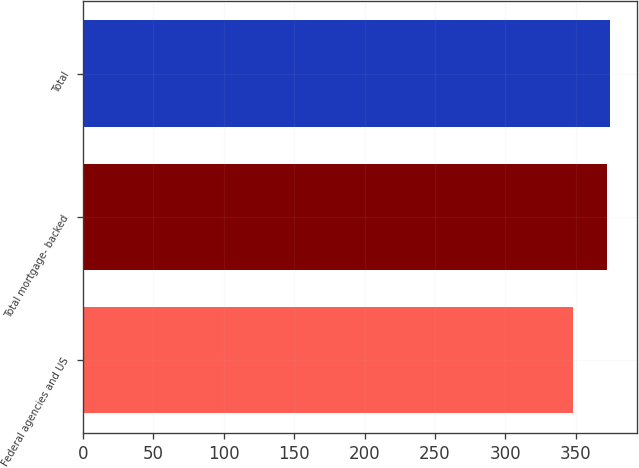Convert chart. <chart><loc_0><loc_0><loc_500><loc_500><bar_chart><fcel>Federal agencies and US<fcel>Total mortgage- backed<fcel>Total<nl><fcel>348<fcel>372<fcel>374.5<nl></chart> 